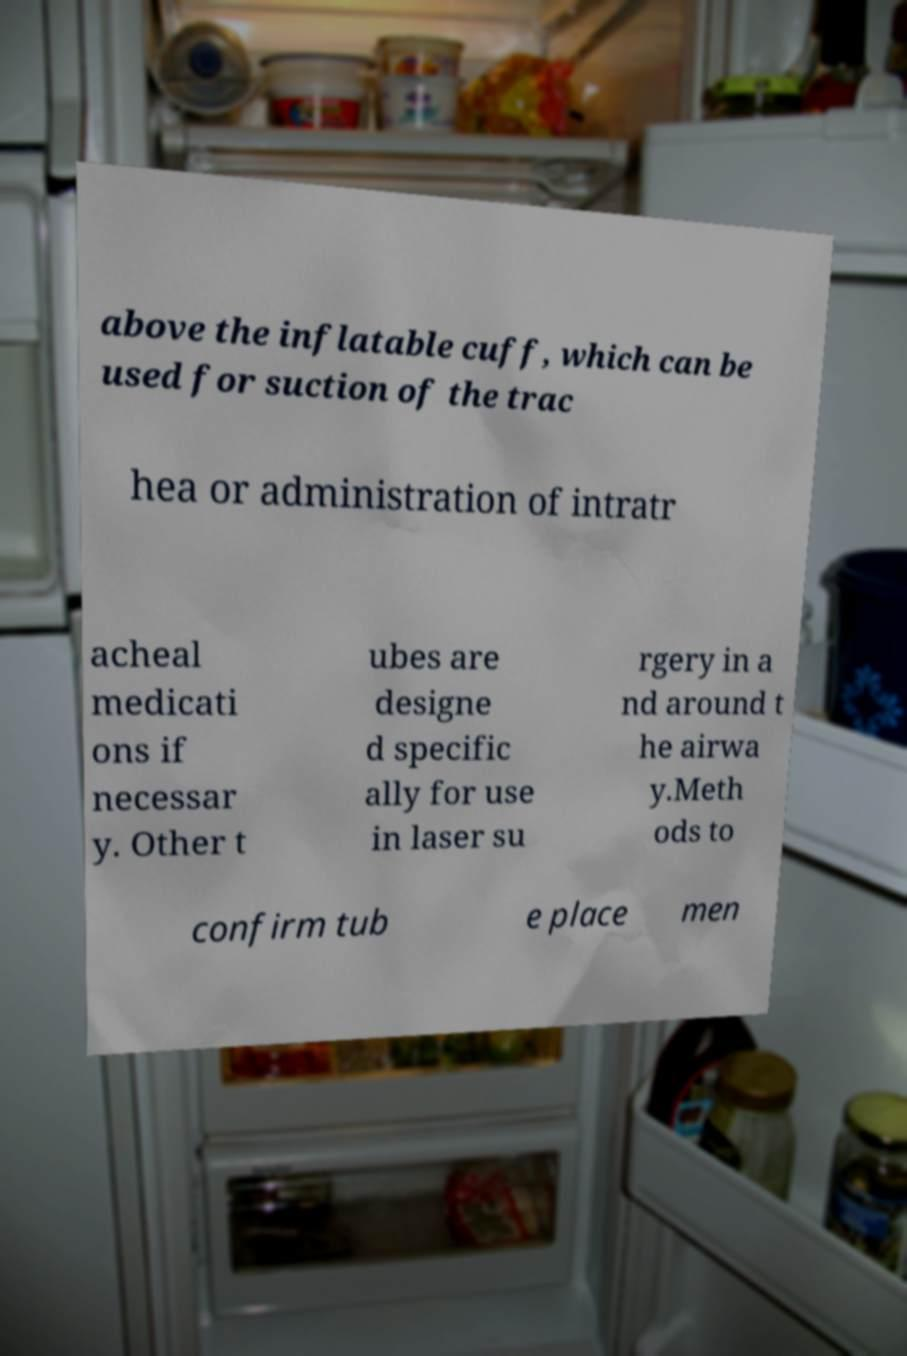Could you assist in decoding the text presented in this image and type it out clearly? above the inflatable cuff, which can be used for suction of the trac hea or administration of intratr acheal medicati ons if necessar y. Other t ubes are designe d specific ally for use in laser su rgery in a nd around t he airwa y.Meth ods to confirm tub e place men 